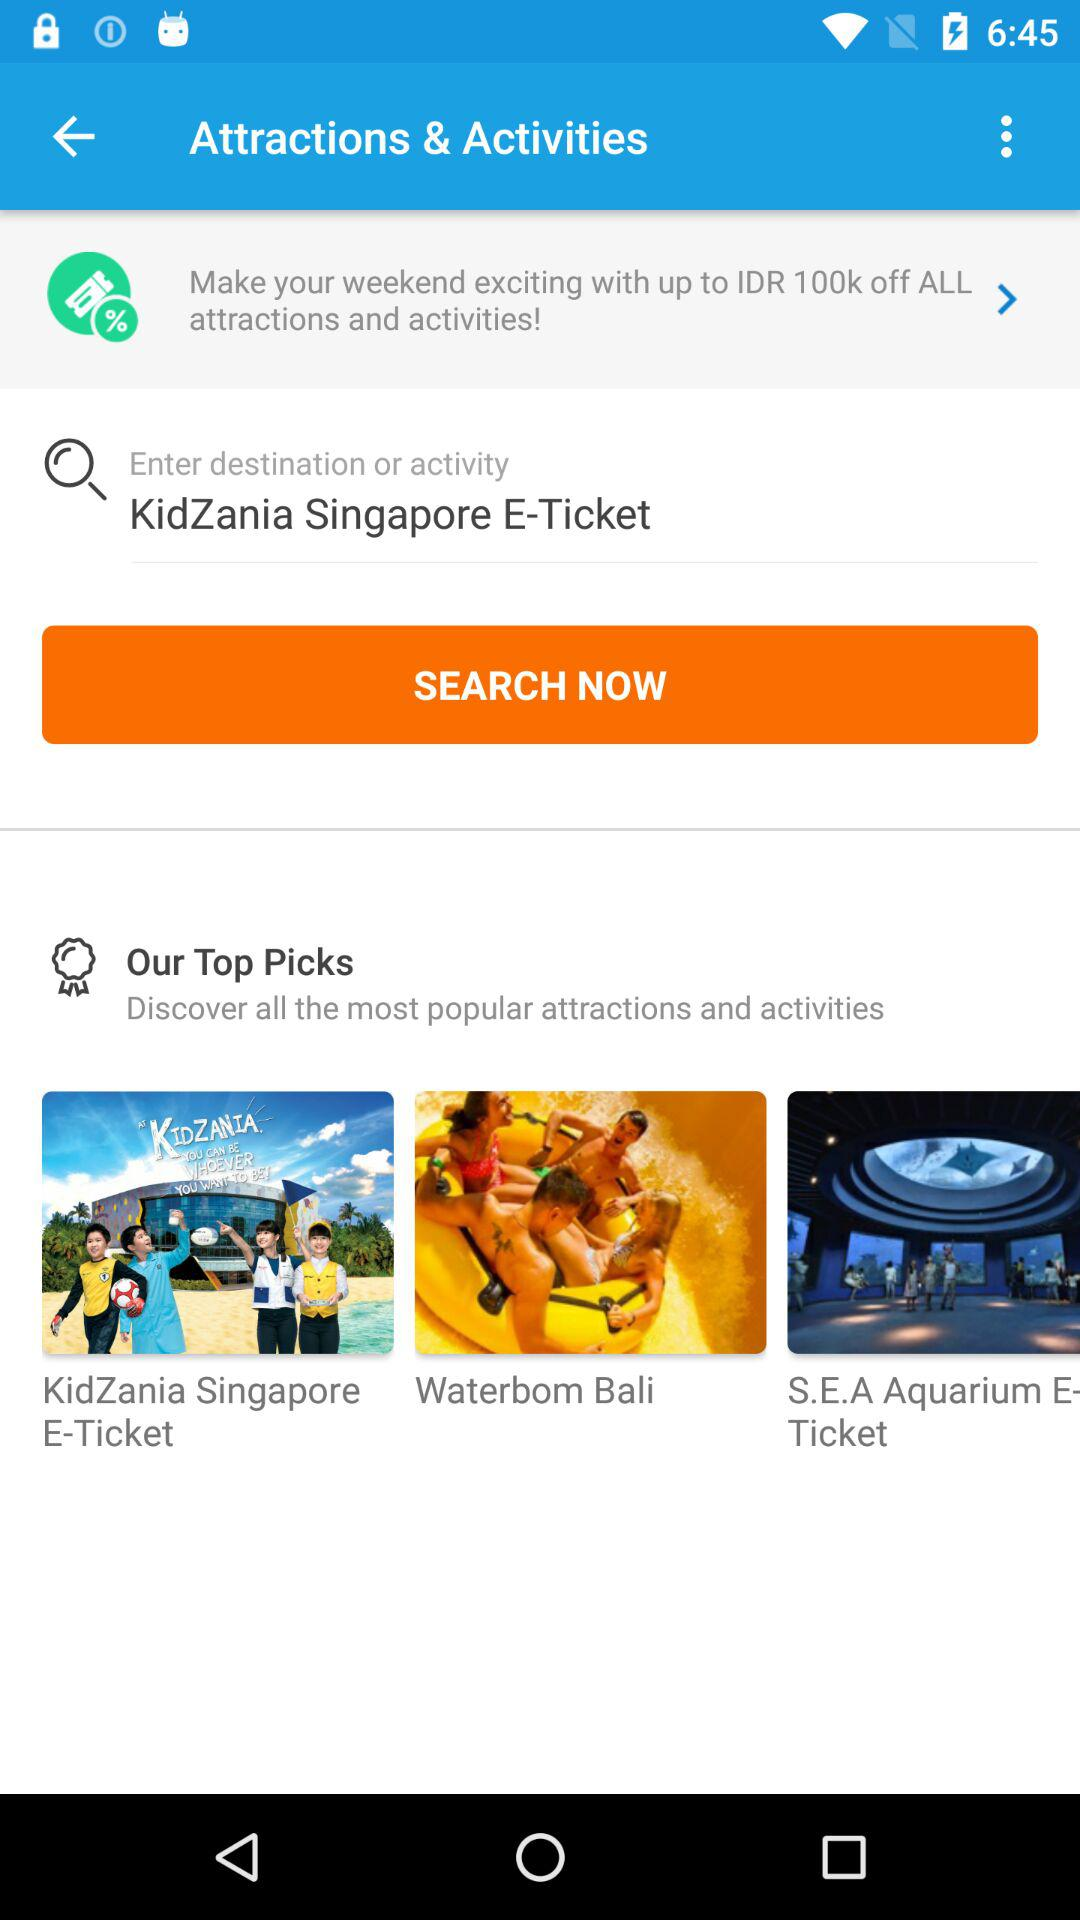What activities are included in top picks? The activities are "KidZania Singapore E-Ticket", "Waterbom Bali" and "S.E.A Aquarium E-Ticket". 